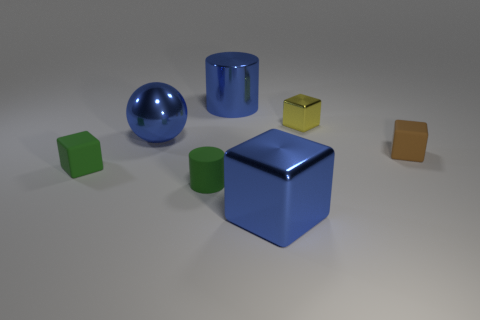Are there any brown cylinders?
Your answer should be compact. No. The small matte block that is to the right of the big blue cylinder is what color?
Make the answer very short. Brown. There is a yellow thing that is the same size as the green rubber cylinder; what is it made of?
Your response must be concise. Metal. How many other things are there of the same material as the brown thing?
Offer a terse response. 2. What color is the thing that is both to the left of the small yellow object and behind the metallic ball?
Provide a short and direct response. Blue. What number of things are either brown cubes that are right of the big block or tiny metallic objects?
Your answer should be very brief. 2. What number of other things are the same color as the small metallic thing?
Give a very brief answer. 0. Is the number of tiny metallic cubes that are in front of the large metal block the same as the number of tiny purple things?
Provide a short and direct response. Yes. There is a matte thing that is right of the small yellow object right of the large blue metal cube; how many brown rubber cubes are to the left of it?
Your answer should be compact. 0. There is a green matte cylinder; is its size the same as the blue object on the right side of the large shiny cylinder?
Offer a terse response. No. 